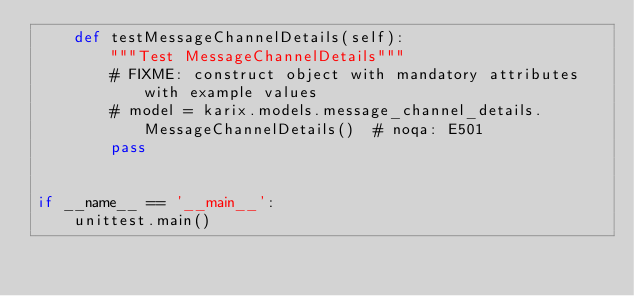Convert code to text. <code><loc_0><loc_0><loc_500><loc_500><_Python_>    def testMessageChannelDetails(self):
        """Test MessageChannelDetails"""
        # FIXME: construct object with mandatory attributes with example values
        # model = karix.models.message_channel_details.MessageChannelDetails()  # noqa: E501
        pass


if __name__ == '__main__':
    unittest.main()
</code> 